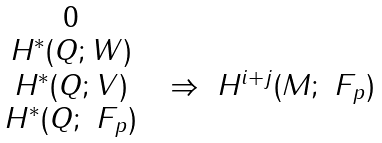<formula> <loc_0><loc_0><loc_500><loc_500>\begin{matrix} 0 & & & \\ H ^ { * } ( Q ; W ) & & & \\ H ^ { * } ( Q ; V ) & & \Rightarrow & H ^ { i + j } ( M ; \ F _ { p } ) \\ H ^ { * } ( Q ; \ F _ { p } ) & & & \end{matrix}</formula> 